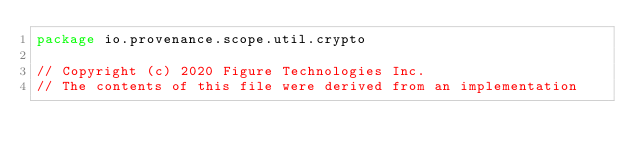Convert code to text. <code><loc_0><loc_0><loc_500><loc_500><_Kotlin_>package io.provenance.scope.util.crypto

// Copyright (c) 2020 Figure Technologies Inc.
// The contents of this file were derived from an implementation</code> 